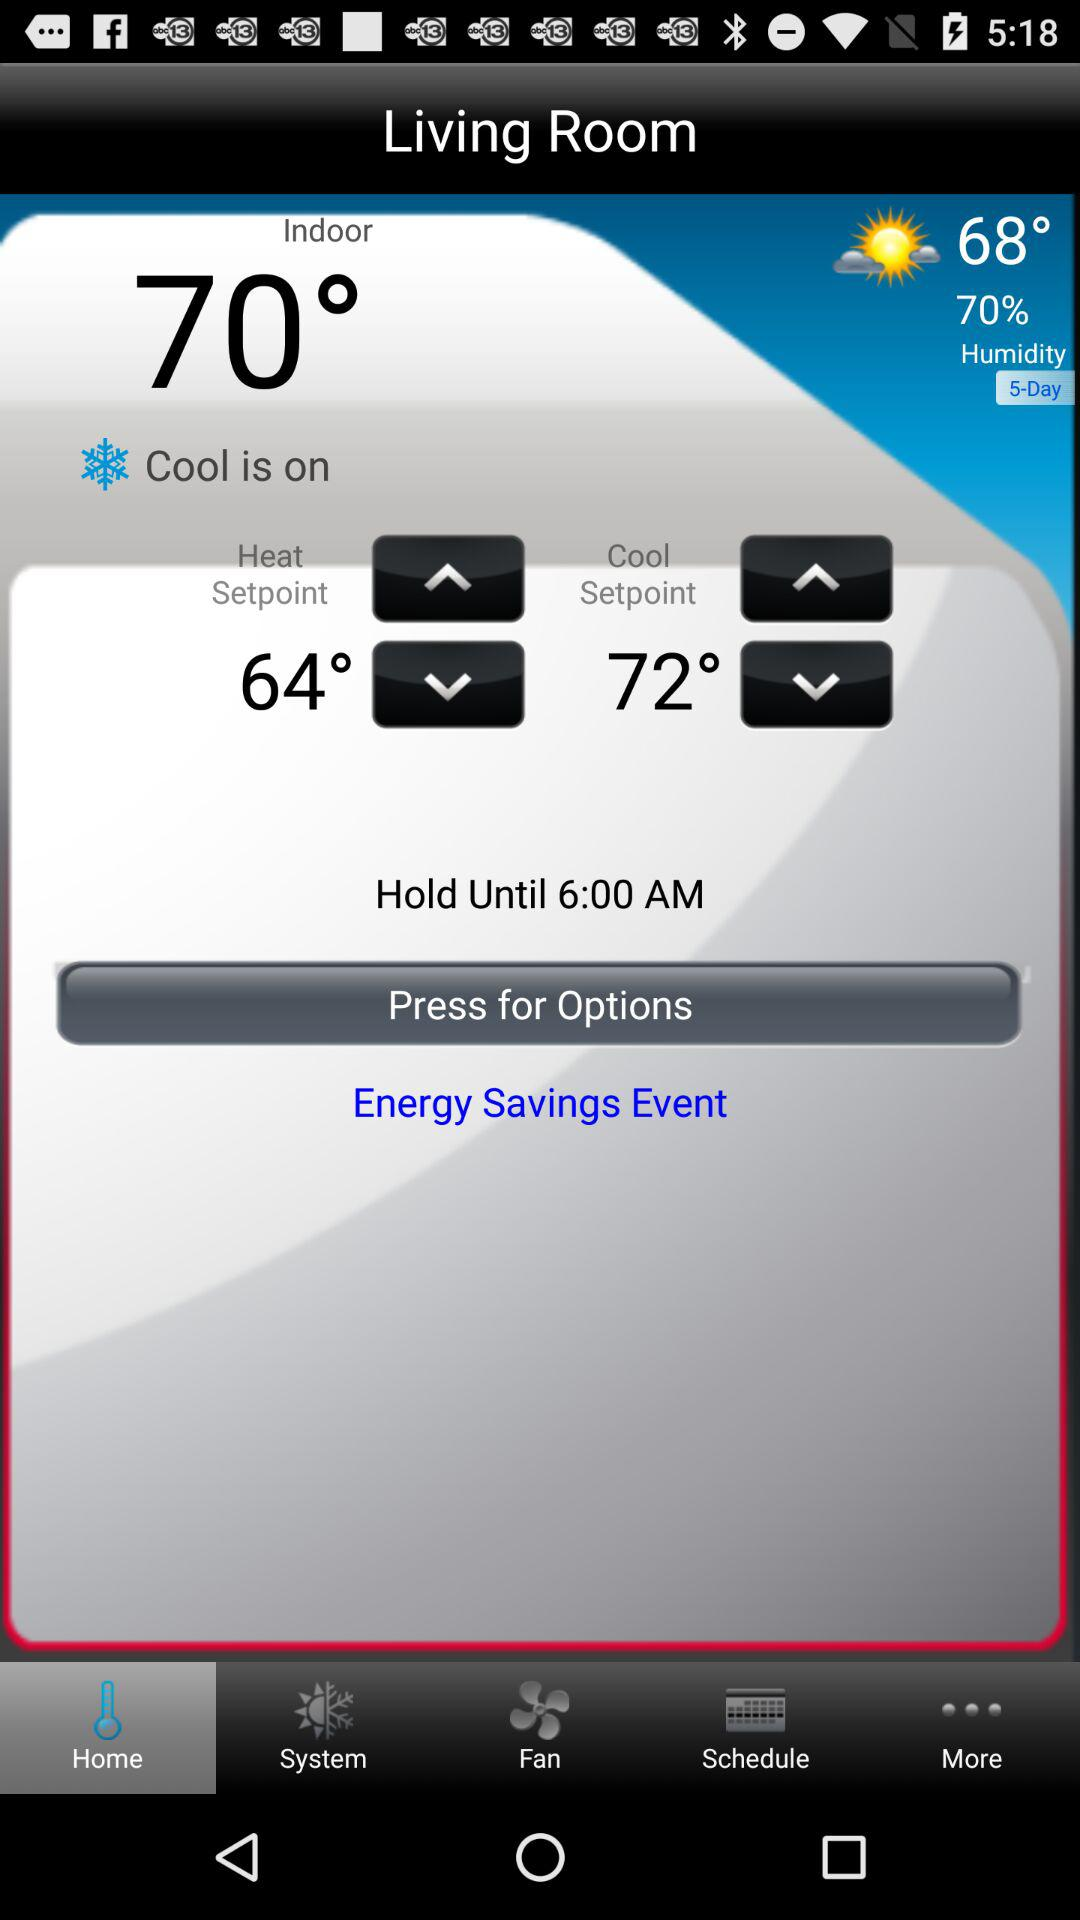What is the heat setpoint? The heat setpoint is 64°. 